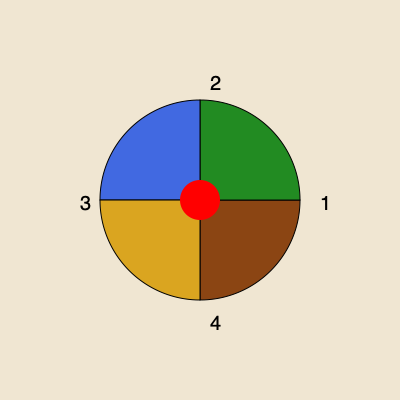In an ancient tome, you discover a mysterious circular map divided into four quadrants. Each quadrant represents a different magical realm: the Enchanted Forest, the Misty Mountains, the Sunken City, and the Desert of Illusions. The map pieces can be rotated, and you need to arrange them correctly to reveal the location of a hidden artifact. If the Enchanted Forest (green) should be in the northeast, the Misty Mountains (blue) in the northwest, the Sunken City (brown) in the southeast, and the Desert of Illusions (gold) in the southwest, in what order should the numbered pieces be arranged, starting from the upper right and moving clockwise? To solve this puzzle, let's follow these steps:

1. Identify the current positions of the realms:
   - Piece 1 (upper right): brown (Sunken City)
   - Piece 2 (upper left): green (Enchanted Forest)
   - Piece 3 (lower left): blue (Misty Mountains)
   - Piece 4 (lower right): gold (Desert of Illusions)

2. Determine the correct positions:
   - Northeast (upper right): Enchanted Forest (green)
   - Northwest (upper left): Misty Mountains (blue)
   - Southeast (lower right): Sunken City (brown)
   - Southwest (lower left): Desert of Illusions (gold)

3. Rearrange the pieces:
   - Piece 2 (green) should move to the upper right (1st position)
   - Piece 3 (blue) should move to the upper left (2nd position)
   - Piece 1 (brown) should move to the lower right (3rd position)
   - Piece 4 (gold) should move to the lower left (4th position)

4. The final order, starting from the upper right and moving clockwise:
   2 (Enchanted Forest), 3 (Misty Mountains), 1 (Sunken City), 4 (Desert of Illusions)
Answer: 2, 3, 1, 4 